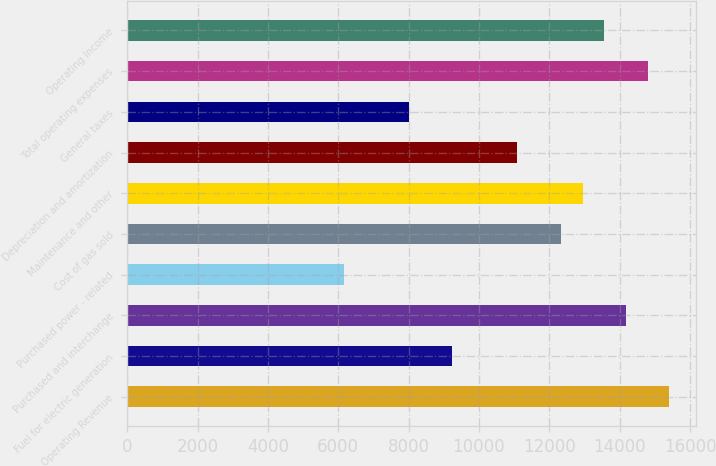Convert chart. <chart><loc_0><loc_0><loc_500><loc_500><bar_chart><fcel>Operating Revenue<fcel>Fuel for electric generation<fcel>Purchased and interchange<fcel>Purchased power - related<fcel>Cost of gas sold<fcel>Maintenance and other<fcel>Depreciation and amortization<fcel>General taxes<fcel>Total operating expenses<fcel>Operating Income<nl><fcel>15411<fcel>9247<fcel>14178.2<fcel>6165<fcel>12329<fcel>12945.4<fcel>11096.2<fcel>8014.2<fcel>14794.6<fcel>13561.8<nl></chart> 